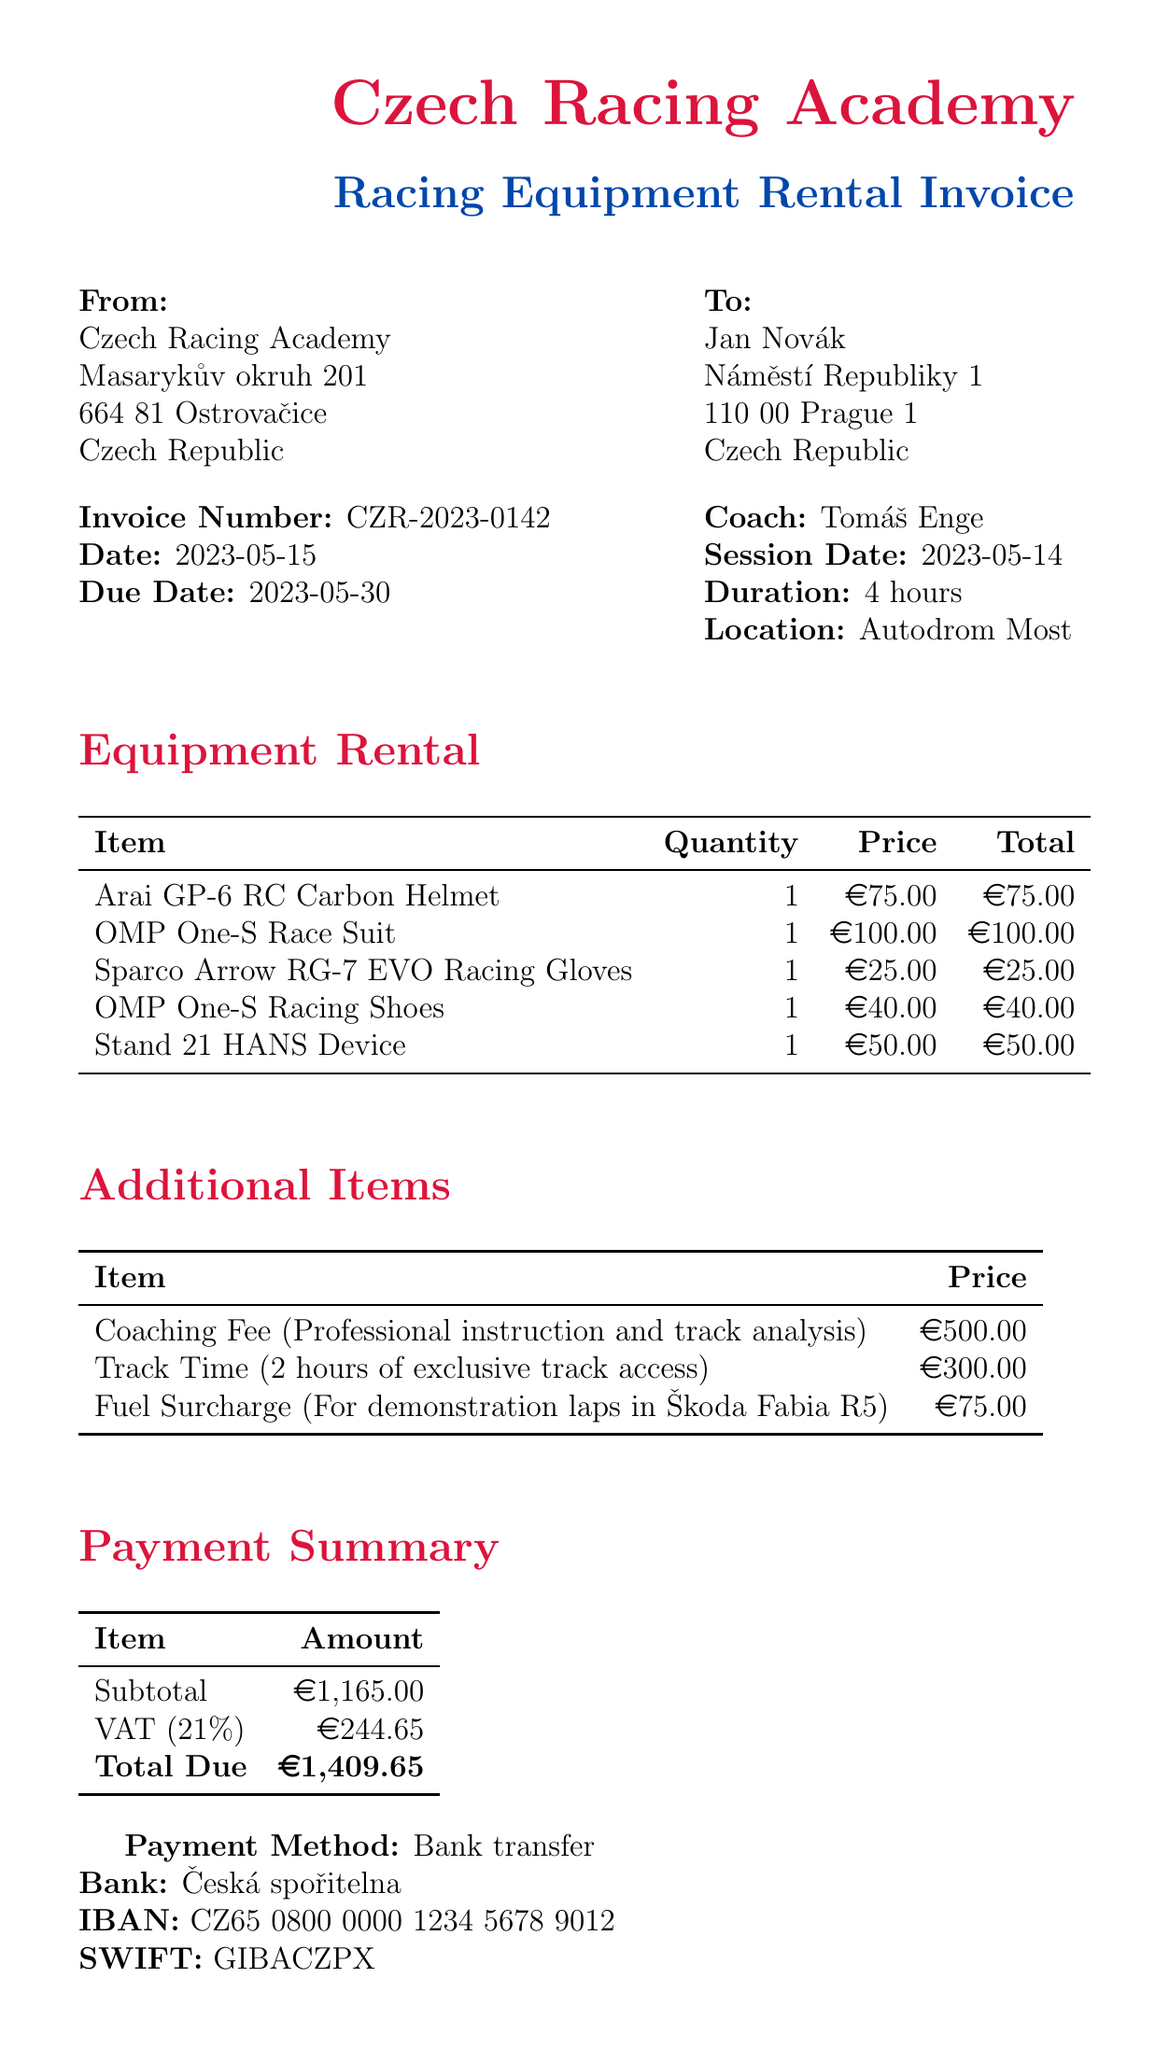what is the invoice number? The invoice number is provided in the invoice details section to uniquely identify the document.
Answer: CZR-2023-0142 who is the coach? The coach's name is mentioned near the top of the document under invoice details.
Answer: Tomáš Enge what is the total due amount? The total due is listed under the payment summary section as the final amount to be paid.
Answer: €1,409.65 when is the payment due date? The due date is specified in the invoice details section for payment to be made.
Answer: 2023-05-30 how many hours was the coaching session? The duration of the coaching session is noted in the session details section.
Answer: 4 hours which racing equipment has the highest rental price? The item prices are listed in the equipment rental section, and the highest rental price can be identified from there.
Answer: OMP One-S Race Suit what is the VAT rate applied? The VAT rate is mentioned in the payment summary section as a percentage added to the subtotal.
Answer: 21% what is the coaching fee? The coaching fee is stated in the additional items section as the cost for professional instruction.
Answer: €500.00 what type of payment method is accepted? The payment method is specified at the end of the document indicating how the payment should be made.
Answer: Bank transfer 